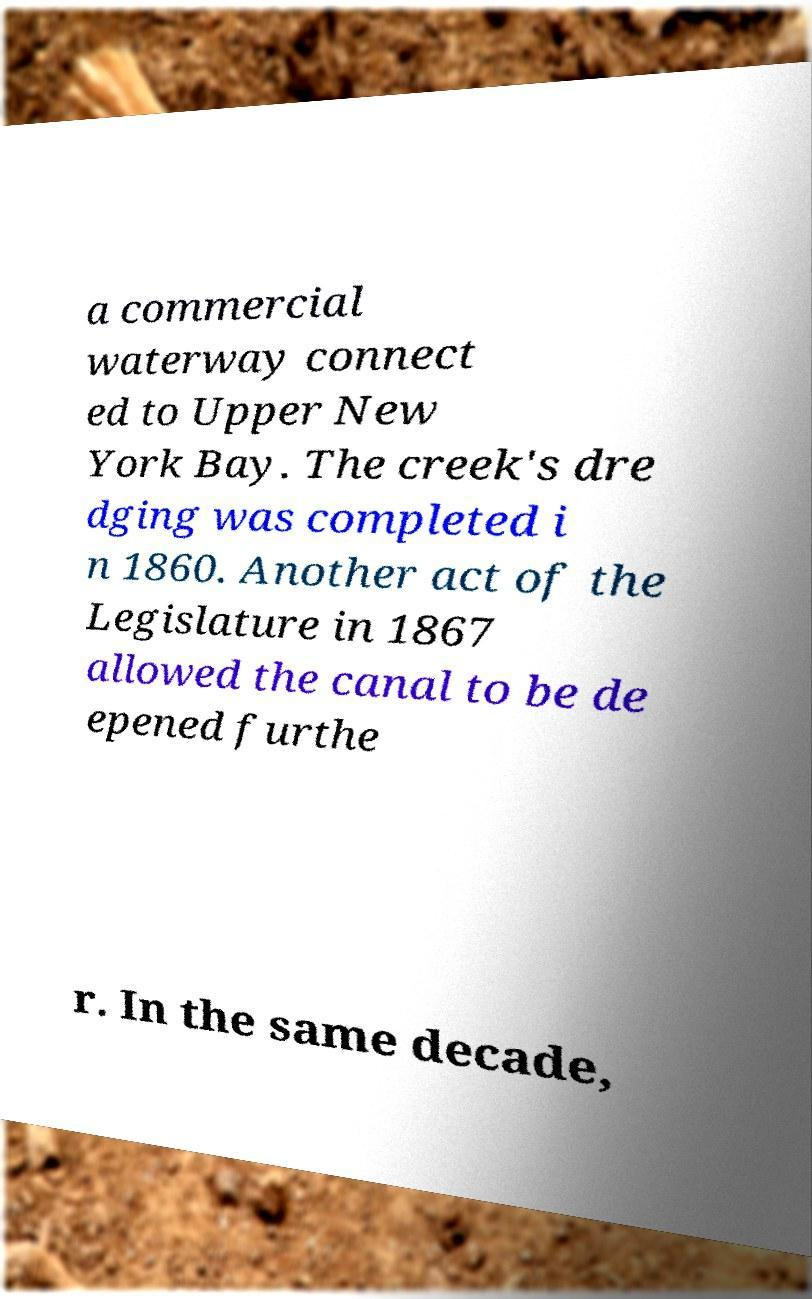What messages or text are displayed in this image? I need them in a readable, typed format. a commercial waterway connect ed to Upper New York Bay. The creek's dre dging was completed i n 1860. Another act of the Legislature in 1867 allowed the canal to be de epened furthe r. In the same decade, 